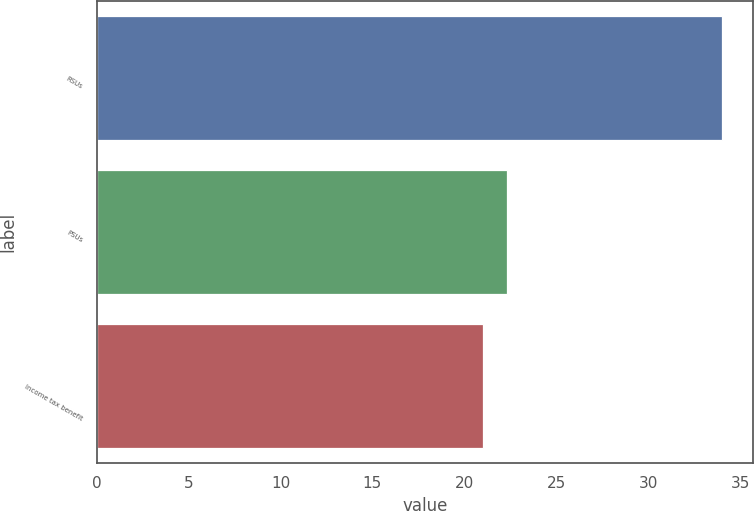Convert chart. <chart><loc_0><loc_0><loc_500><loc_500><bar_chart><fcel>RSUs<fcel>PSUs<fcel>Income tax benefit<nl><fcel>34<fcel>22.3<fcel>21<nl></chart> 